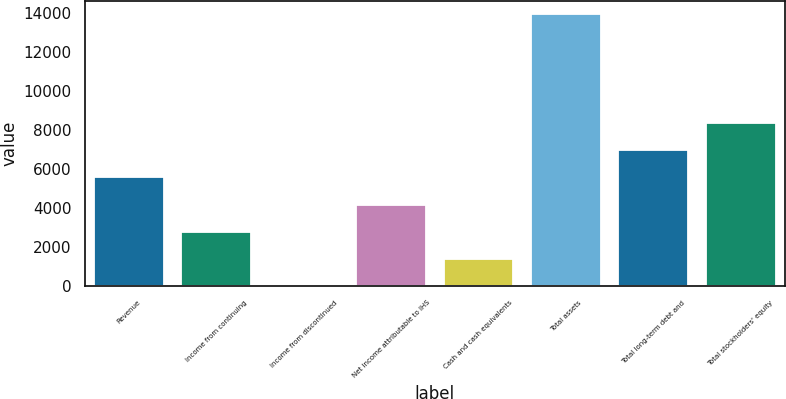Convert chart. <chart><loc_0><loc_0><loc_500><loc_500><bar_chart><fcel>Revenue<fcel>Income from continuing<fcel>Income from discontinued<fcel>Net income attributable to IHS<fcel>Cash and cash equivalents<fcel>Total assets<fcel>Total long-term debt and<fcel>Total stockholders' equity<nl><fcel>5580.16<fcel>2794.68<fcel>9.2<fcel>4187.42<fcel>1401.94<fcel>13936.6<fcel>6972.9<fcel>8365.64<nl></chart> 